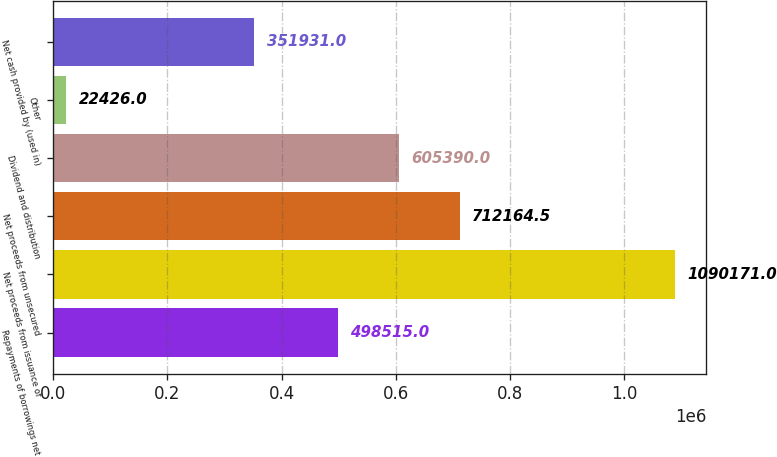Convert chart. <chart><loc_0><loc_0><loc_500><loc_500><bar_chart><fcel>Repayments of borrowings net<fcel>Net proceeds from issuance of<fcel>Net proceeds from unsecured<fcel>Dividend and distribution<fcel>Other<fcel>Net cash provided by (used in)<nl><fcel>498515<fcel>1.09017e+06<fcel>712164<fcel>605390<fcel>22426<fcel>351931<nl></chart> 